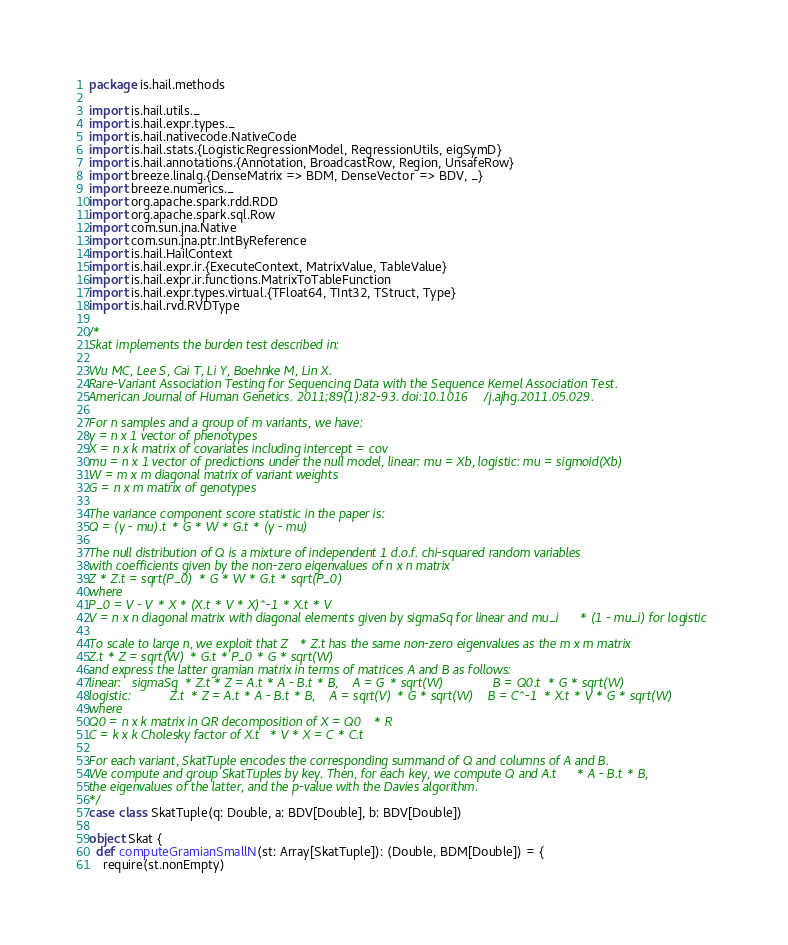<code> <loc_0><loc_0><loc_500><loc_500><_Scala_>package is.hail.methods

import is.hail.utils._
import is.hail.expr.types._
import is.hail.nativecode.NativeCode
import is.hail.stats.{LogisticRegressionModel, RegressionUtils, eigSymD}
import is.hail.annotations.{Annotation, BroadcastRow, Region, UnsafeRow}
import breeze.linalg.{DenseMatrix => BDM, DenseVector => BDV, _}
import breeze.numerics._
import org.apache.spark.rdd.RDD
import org.apache.spark.sql.Row
import com.sun.jna.Native
import com.sun.jna.ptr.IntByReference
import is.hail.HailContext
import is.hail.expr.ir.{ExecuteContext, MatrixValue, TableValue}
import is.hail.expr.ir.functions.MatrixToTableFunction
import is.hail.expr.types.virtual.{TFloat64, TInt32, TStruct, Type}
import is.hail.rvd.RVDType

/*
Skat implements the burden test described in:

Wu MC, Lee S, Cai T, Li Y, Boehnke M, Lin X.
Rare-Variant Association Testing for Sequencing Data with the Sequence Kernel Association Test.
American Journal of Human Genetics. 2011;89(1):82-93. doi:10.1016/j.ajhg.2011.05.029.

For n samples and a group of m variants, we have:
y = n x 1 vector of phenotypes
X = n x k matrix of covariates including intercept = cov
mu = n x 1 vector of predictions under the null model, linear: mu = Xb, logistic: mu = sigmoid(Xb)
W = m x m diagonal matrix of variant weights
G = n x m matrix of genotypes

The variance component score statistic in the paper is:
Q = (y - mu).t * G * W * G.t * (y - mu)

The null distribution of Q is a mixture of independent 1 d.o.f. chi-squared random variables
with coefficients given by the non-zero eigenvalues of n x n matrix
Z * Z.t = sqrt(P_0) * G * W * G.t * sqrt(P_0)
where
P_0 = V - V * X * (X.t * V * X)^-1 * X.t * V
V = n x n diagonal matrix with diagonal elements given by sigmaSq for linear and mu_i * (1 - mu_i) for logistic

To scale to large n, we exploit that Z * Z.t has the same non-zero eigenvalues as the m x m matrix
Z.t * Z = sqrt(W) * G.t * P_0 * G * sqrt(W)
and express the latter gramian matrix in terms of matrices A and B as follows:
linear:   sigmaSq * Z.t * Z = A.t * A - B.t * B,    A = G * sqrt(W)              B = Q0.t * G * sqrt(W)
logistic:           Z.t * Z = A.t * A - B.t * B,    A = sqrt(V) * G * sqrt(W)    B = C^-1 * X.t * V * G * sqrt(W)
where
Q0 = n x k matrix in QR decomposition of X = Q0 * R
C = k x k Cholesky factor of X.t * V * X = C * C.t

For each variant, SkatTuple encodes the corresponding summand of Q and columns of A and B.
We compute and group SkatTuples by key. Then, for each key, we compute Q and A.t * A - B.t * B,
the eigenvalues of the latter, and the p-value with the Davies algorithm.
*/
case class SkatTuple(q: Double, a: BDV[Double], b: BDV[Double])

object Skat {
  def computeGramianSmallN(st: Array[SkatTuple]): (Double, BDM[Double]) = {
    require(st.nonEmpty)</code> 